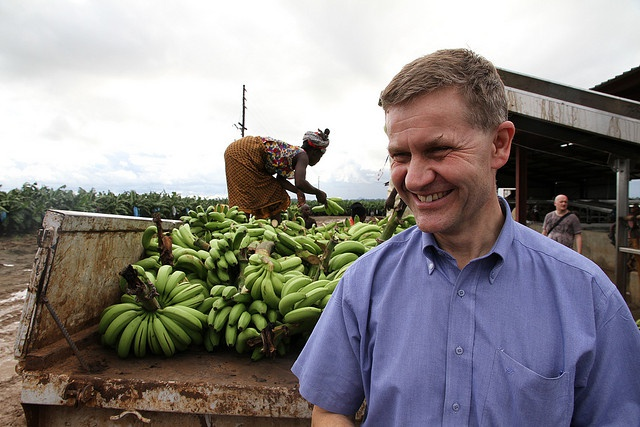Describe the objects in this image and their specific colors. I can see people in lightgray, gray, purple, brown, and maroon tones, truck in lightgray, black, maroon, and gray tones, banana in lightgray, black, darkgreen, olive, and khaki tones, banana in lightgray, black, darkgreen, and olive tones, and people in lightgray, black, maroon, and brown tones in this image. 